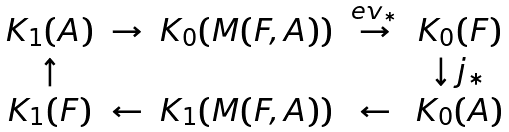Convert formula to latex. <formula><loc_0><loc_0><loc_500><loc_500>\begin{array} { c c c c c } K _ { 1 } ( A ) & \to & K _ { 0 } ( M ( F , A ) ) & \stackrel { e v _ { * } } { \to } & K _ { 0 } ( F ) \\ \uparrow & & & & \downarrow j _ { * } \\ K _ { 1 } ( F ) & \leftarrow & K _ { 1 } ( M ( F , A ) ) & \leftarrow & K _ { 0 } ( A ) \end{array}</formula> 